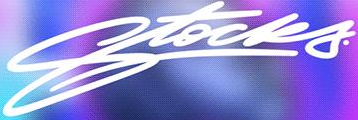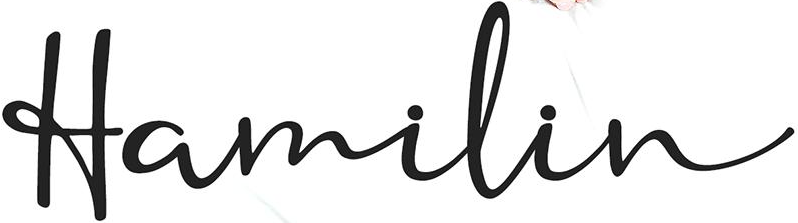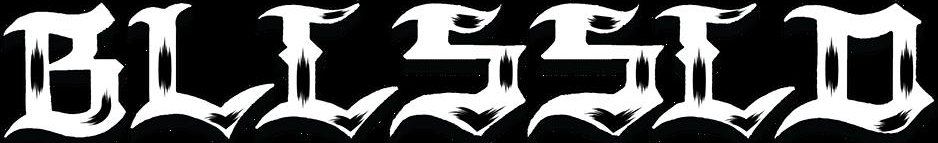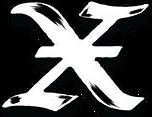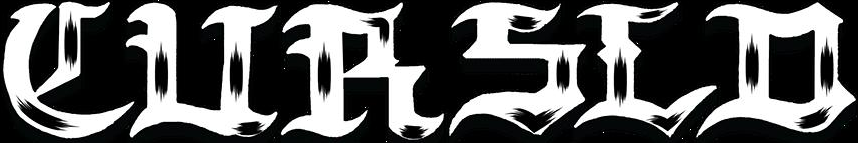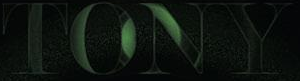Read the text from these images in sequence, separated by a semicolon. Stocks; Hamilin; BLLSSLD; X; CURSLD; TONY 